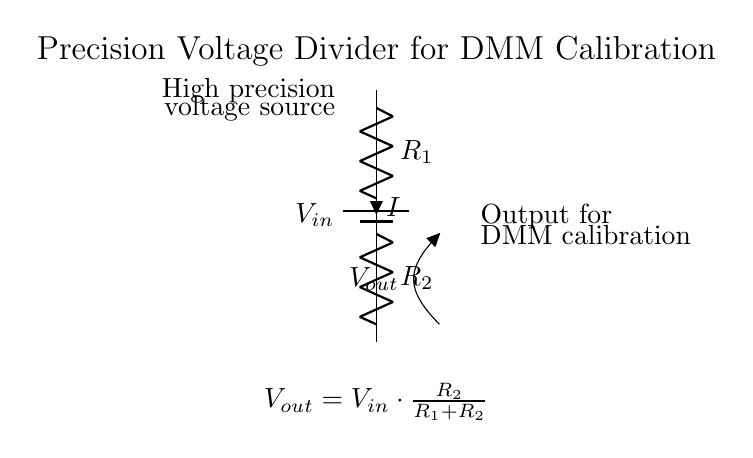What is the type of source in this circuit? The circuit uses a battery as the power supply, as indicated in the diagram. Specifically, it's labeled as a battery component providing the input voltage.
Answer: battery What is the voltage equation shown at the bottom of the circuit? The equation given states the relationship of the output voltage concerning the input voltage and the resistances. The output voltage is expressed as Vout equals Vin times the fraction of R2 over the sum of R1 and R2.
Answer: Vout = Vin * (R2 / (R1 + R2)) What are the two resistors in the circuit? The resistors are labeled as R1 and R2, both identified in the circuit. R1 is located in the upper part of the diagram, and R2 is in the lower part.
Answer: R1 and R2 What is the purpose of this precision voltage divider? The purpose is to provide a stable output voltage for calibrating digital multimeters. This is specified in the diagram as it states "Output for DMM calibration".
Answer: DMM calibration How can the output voltage be adjusted in this circuit? The output voltage can be adjusted by changing the values of the resistors R1 and R2, which would alter the ratio of the voltage divider as described in the voltage equation.
Answer: By changing R1 and R2 What does the current indicate in the circuit diagram? The current, denoted as I, indicates the flow of electric charge through the resistor R1. The direction suggested in the diagram shows it flowing downward through the resistors.
Answer: It indicates electric current flow through R1 What kind of circuit is this categorized as? This circuit is classified as a voltage divider because it is designed to output a fraction of the input voltage based on the resistive values of R1 and R2.
Answer: voltage divider 